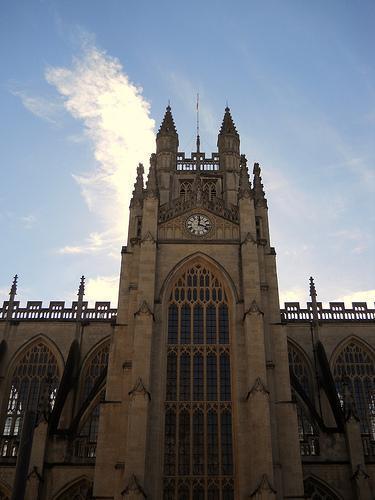How many clocks are there?
Give a very brief answer. 1. 